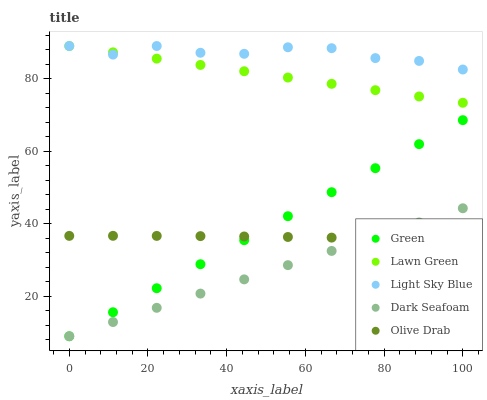Does Dark Seafoam have the minimum area under the curve?
Answer yes or no. Yes. Does Light Sky Blue have the maximum area under the curve?
Answer yes or no. Yes. Does Light Sky Blue have the minimum area under the curve?
Answer yes or no. No. Does Dark Seafoam have the maximum area under the curve?
Answer yes or no. No. Is Dark Seafoam the smoothest?
Answer yes or no. Yes. Is Light Sky Blue the roughest?
Answer yes or no. Yes. Is Light Sky Blue the smoothest?
Answer yes or no. No. Is Dark Seafoam the roughest?
Answer yes or no. No. Does Dark Seafoam have the lowest value?
Answer yes or no. Yes. Does Light Sky Blue have the lowest value?
Answer yes or no. No. Does Light Sky Blue have the highest value?
Answer yes or no. Yes. Does Dark Seafoam have the highest value?
Answer yes or no. No. Is Dark Seafoam less than Lawn Green?
Answer yes or no. Yes. Is Light Sky Blue greater than Green?
Answer yes or no. Yes. Does Lawn Green intersect Light Sky Blue?
Answer yes or no. Yes. Is Lawn Green less than Light Sky Blue?
Answer yes or no. No. Is Lawn Green greater than Light Sky Blue?
Answer yes or no. No. Does Dark Seafoam intersect Lawn Green?
Answer yes or no. No. 